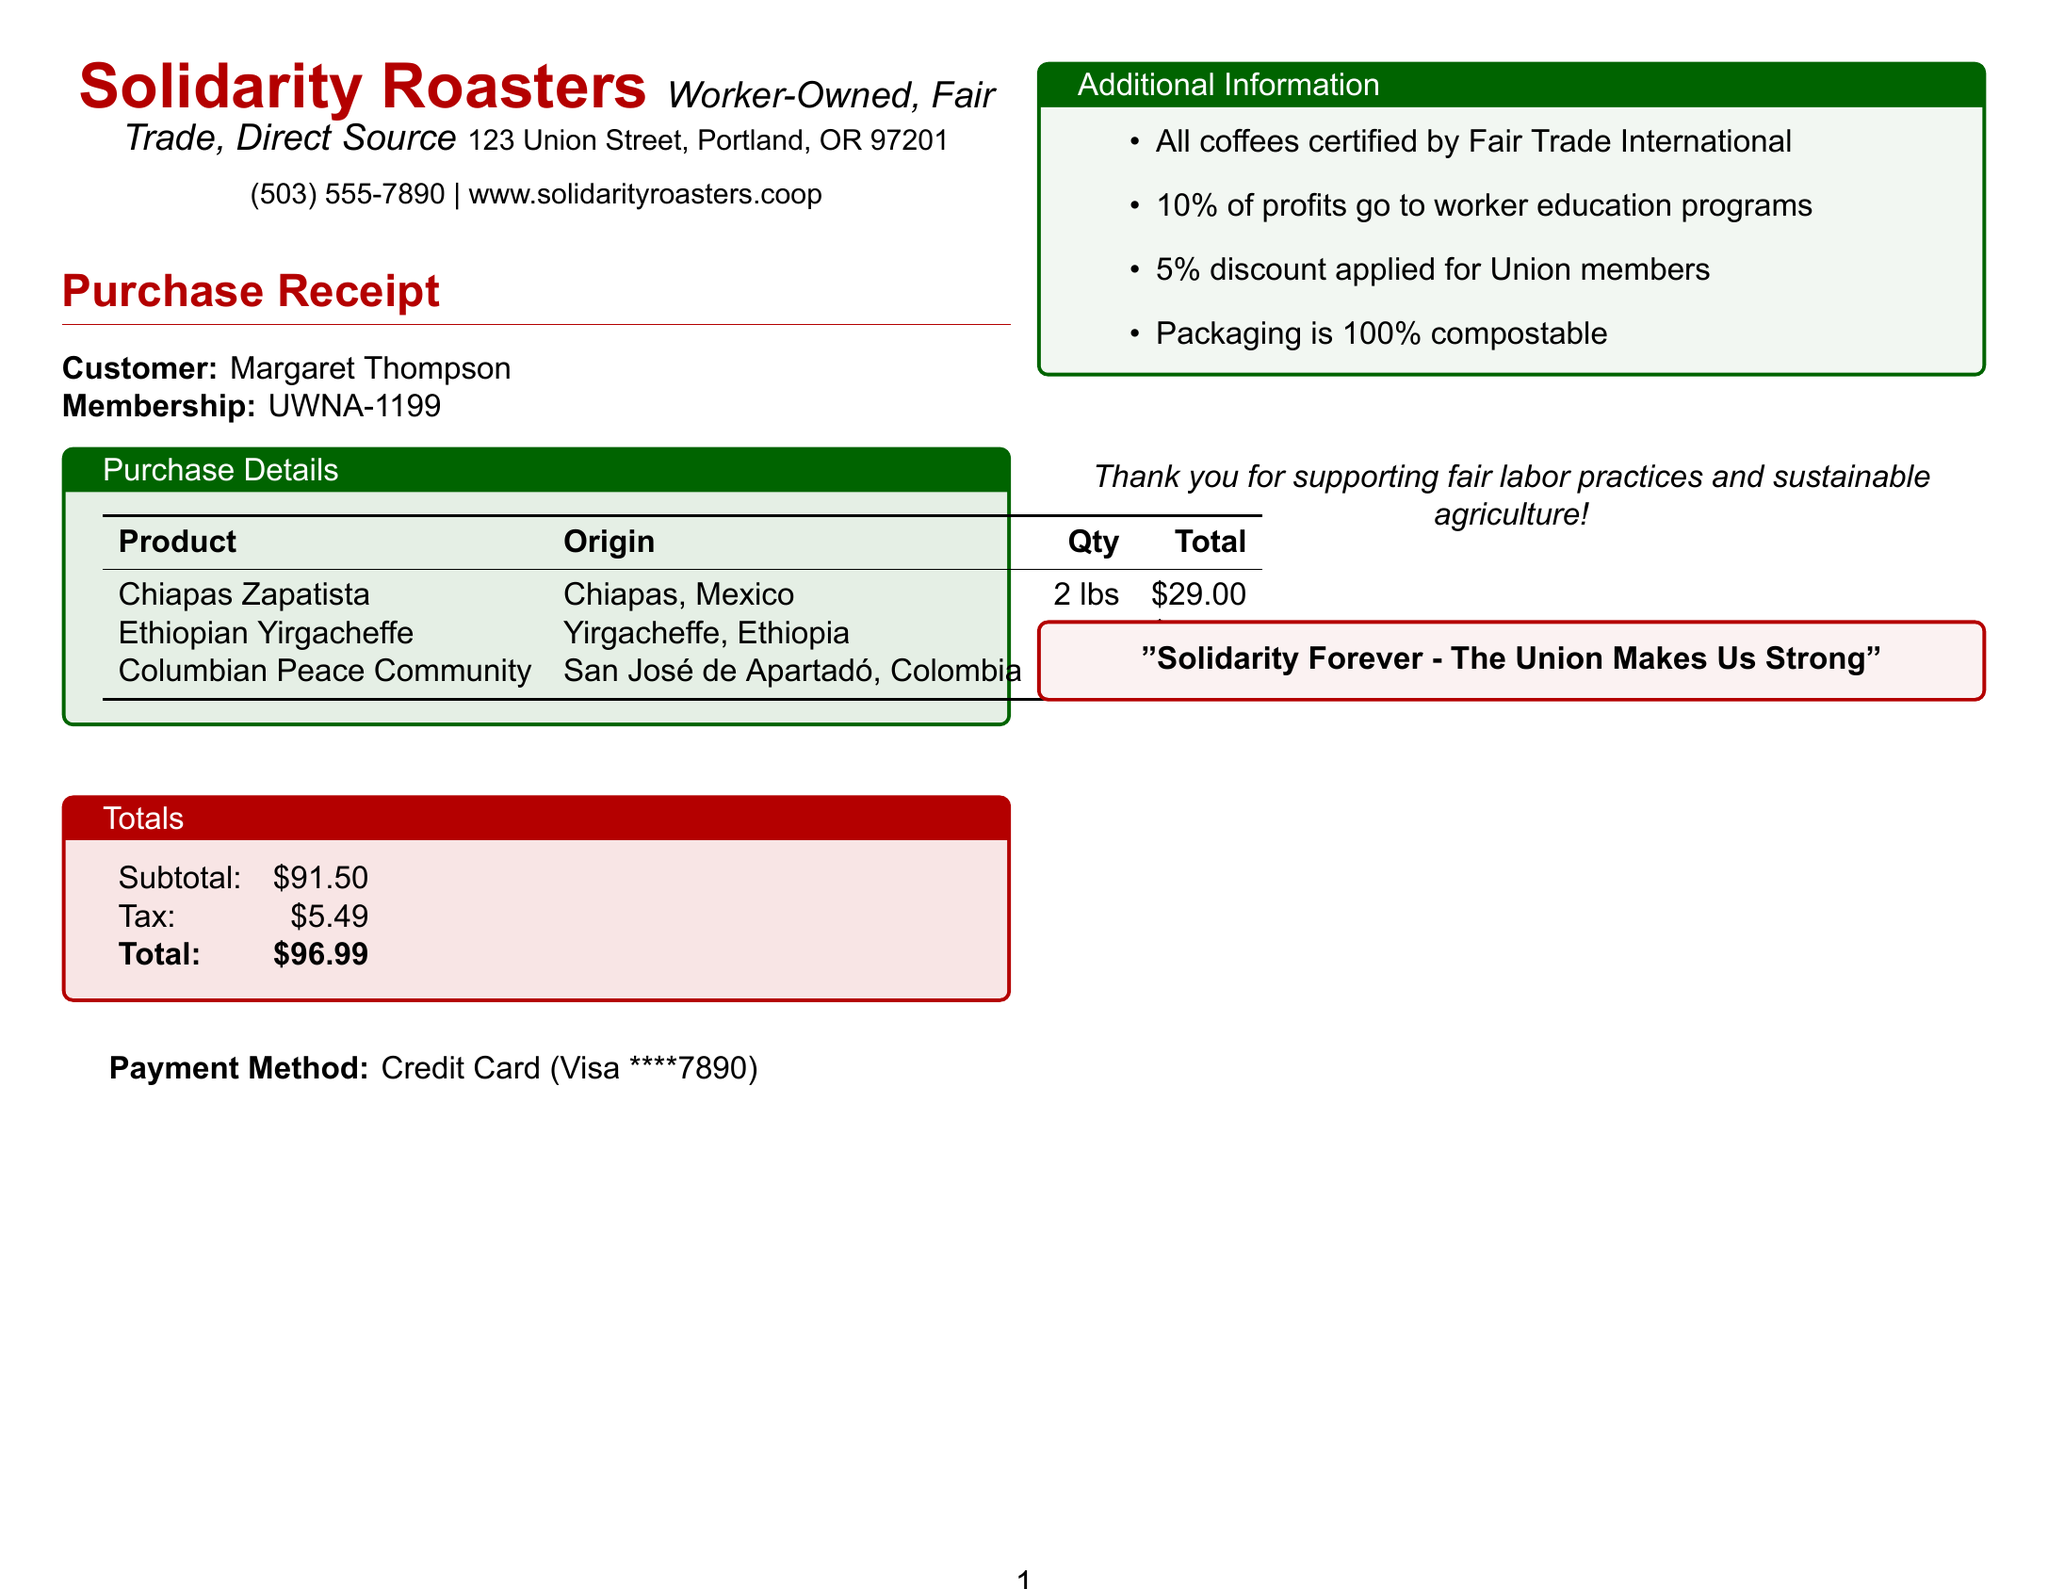What is the name of the company? The name of the company is stated at the top of the receipt and is "Solidarity Roasters."
Answer: Solidarity Roasters What is the total amount paid? The total amount is provided in the "Totals" section of the document, summing up the subtotal and tax.
Answer: $96.99 How many pounds of Ethiopian Yirgacheffe coffee beans were purchased? The quantity is listed in the purchase items section for Ethiopian Yirgacheffe coffee beans.
Answer: 1 lb What percentage of profits goes to worker education programs? This information is provided in the additional info section of the document regarding worker empowerment.
Answer: 10% What discount is applied for union members? The receipt mentions a specific discount for union members in the additional information section.
Answer: 5% What is the origin of the Columbian Peace Community coffee beans? The origin is specified alongside the product name in the purchase details.
Answer: San José de Apartadó, Colombia What type of payment method was used? The payment method is listed in the payment info section of the document.
Answer: Credit Card Which certification do all the coffees have? The certification is mentioned in the additional info section, indicating a quality standard for the coffee.
Answer: Fair Trade International What message is included at the bottom of the receipt? The footer section contains a thank you message expressing support for specific practices.
Answer: Thank you for supporting fair labor practices and sustainable agriculture! 